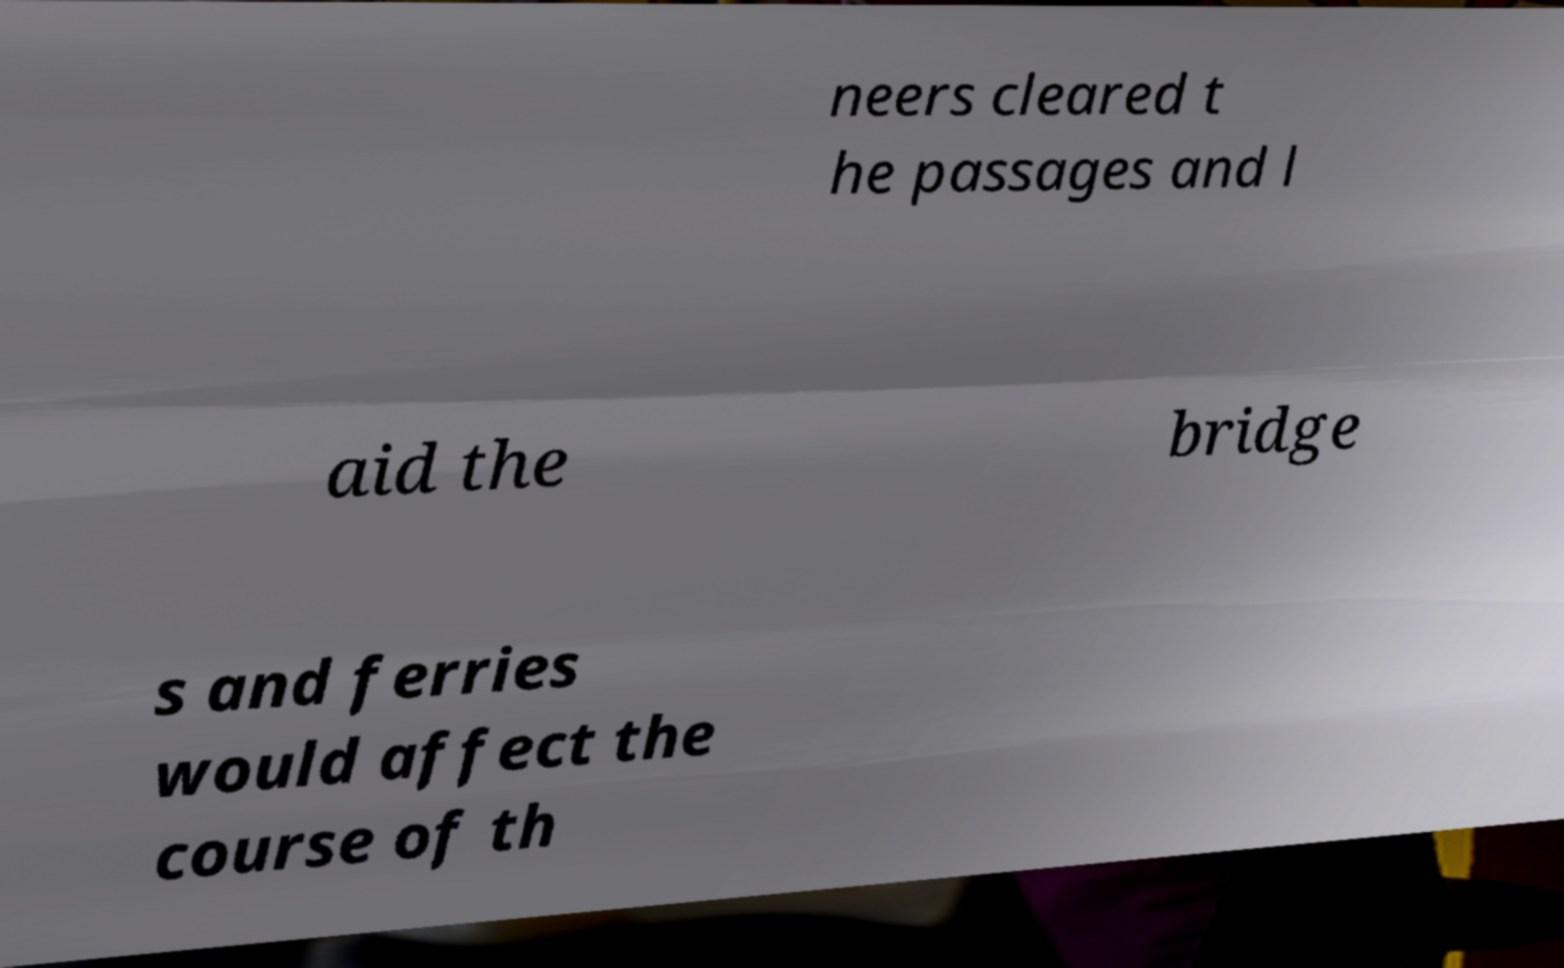For documentation purposes, I need the text within this image transcribed. Could you provide that? neers cleared t he passages and l aid the bridge s and ferries would affect the course of th 